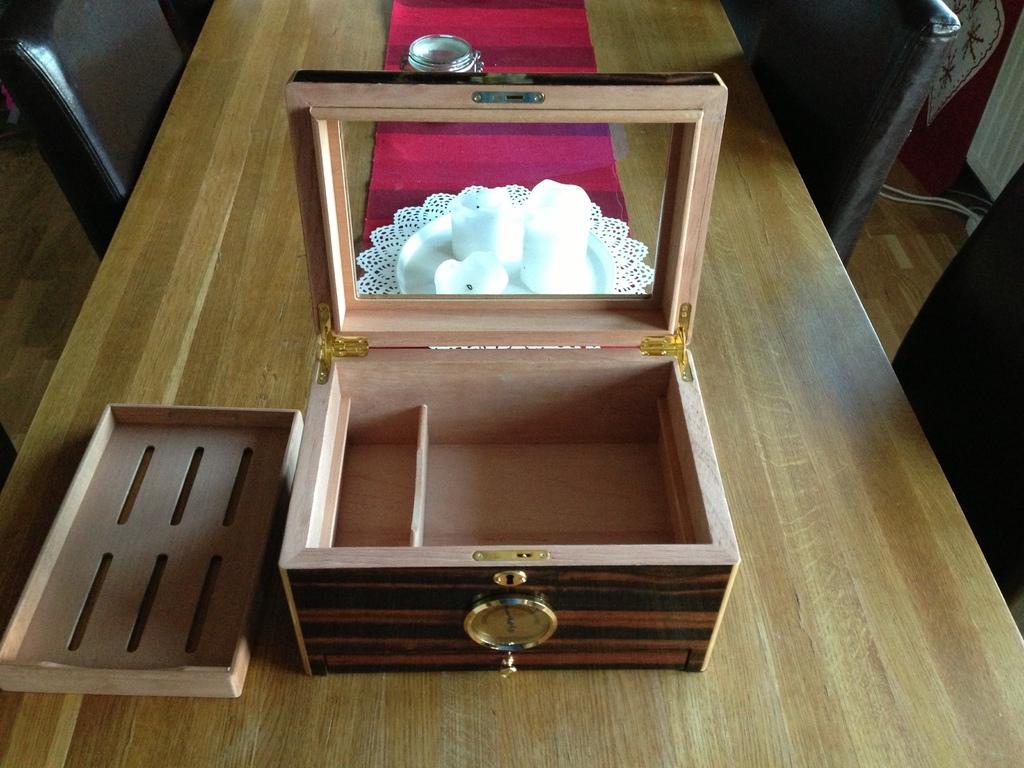Describe this image in one or two sentences. On the table there is a box,candles,plate and beside it there are chairs. 